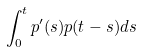Convert formula to latex. <formula><loc_0><loc_0><loc_500><loc_500>\int _ { 0 } ^ { t } p ^ { \prime } ( s ) p ( t - s ) d s</formula> 